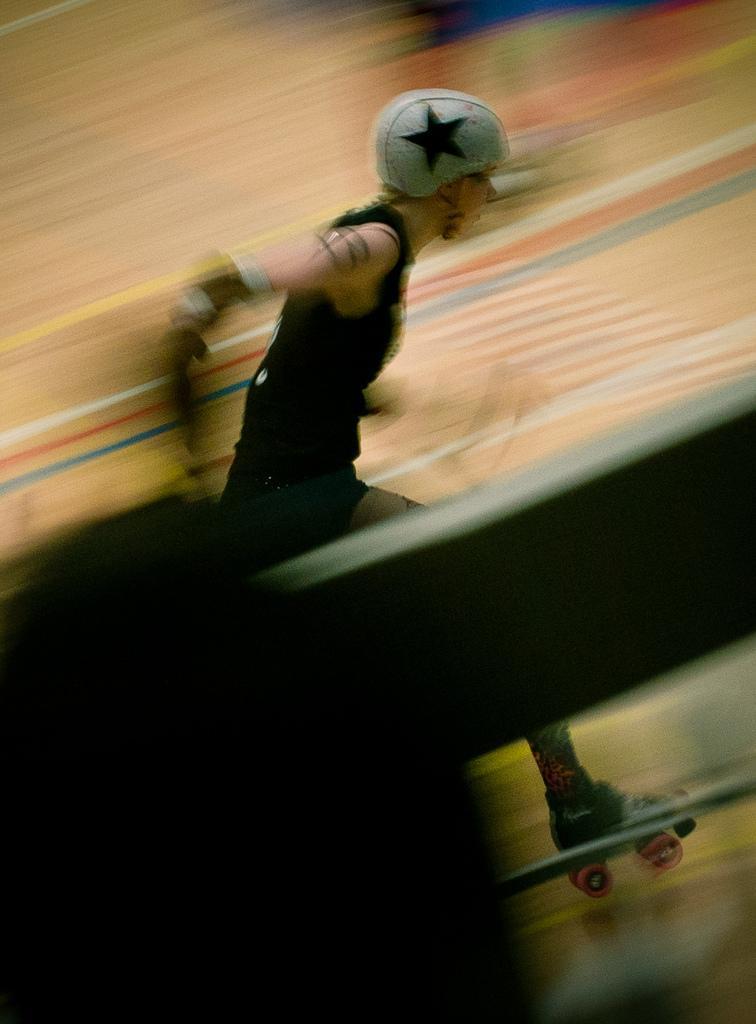Could you give a brief overview of what you see in this image? In this image, I can see a person with a helmet and skate shoe. There is a blurred background. 